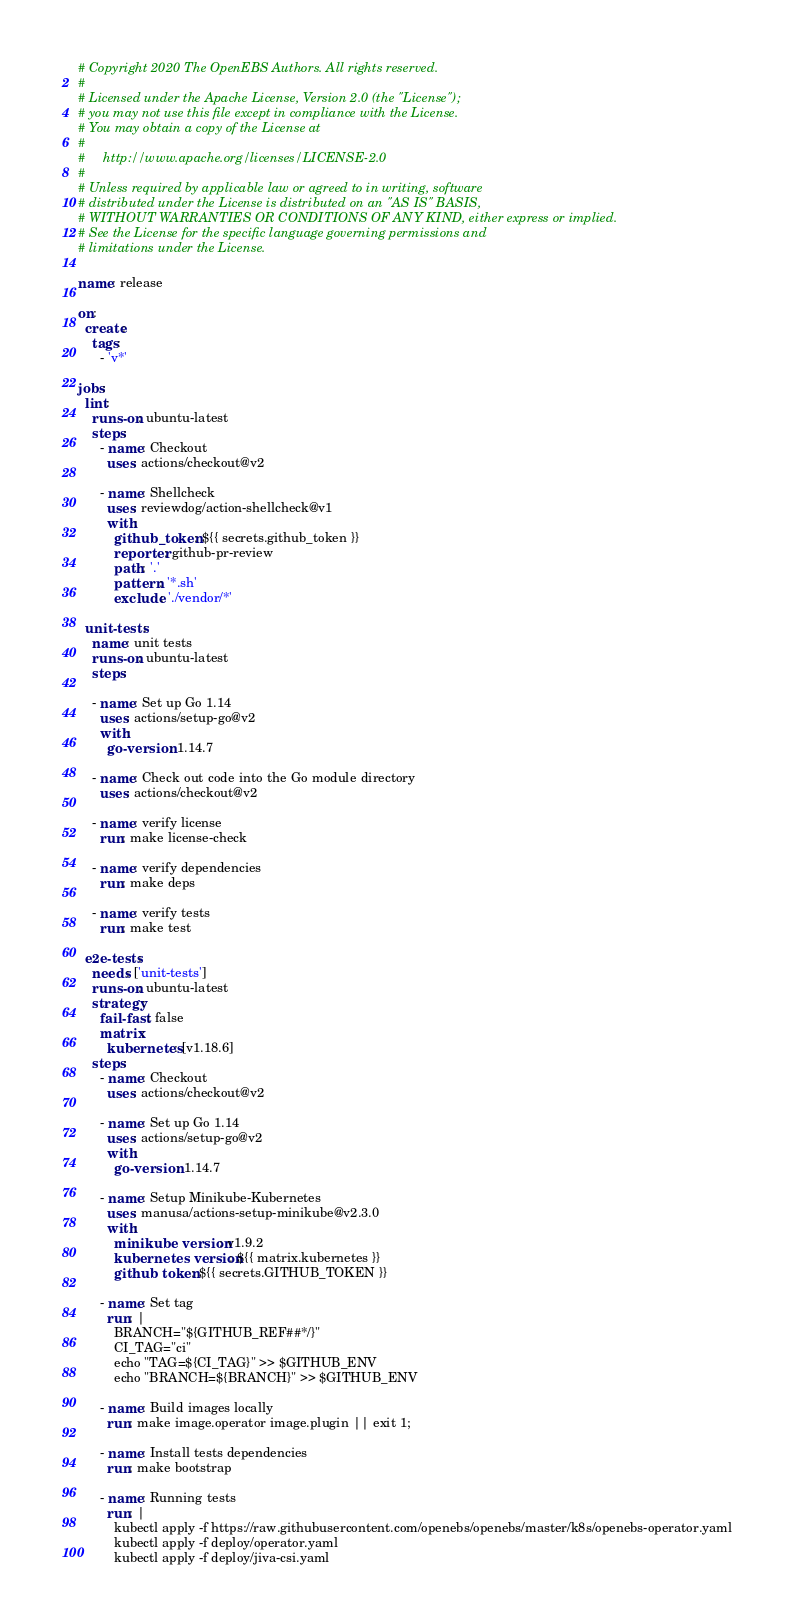Convert code to text. <code><loc_0><loc_0><loc_500><loc_500><_YAML_># Copyright 2020 The OpenEBS Authors. All rights reserved.
#
# Licensed under the Apache License, Version 2.0 (the "License");
# you may not use this file except in compliance with the License.
# You may obtain a copy of the License at
#
#     http://www.apache.org/licenses/LICENSE-2.0
#
# Unless required by applicable law or agreed to in writing, software
# distributed under the License is distributed on an "AS IS" BASIS,
# WITHOUT WARRANTIES OR CONDITIONS OF ANY KIND, either express or implied.
# See the License for the specific language governing permissions and
# limitations under the License.

name: release

on:
  create:
    tags:
      - 'v*'

jobs:
  lint:
    runs-on: ubuntu-latest
    steps:
      - name: Checkout
        uses: actions/checkout@v2

      - name: Shellcheck
        uses: reviewdog/action-shellcheck@v1
        with:
          github_token: ${{ secrets.github_token }}
          reporter: github-pr-review
          path: '.'
          pattern: '*.sh'
          exclude: './vendor/*'

  unit-tests:
    name: unit tests 
    runs-on: ubuntu-latest
    steps:

    - name: Set up Go 1.14
      uses: actions/setup-go@v2
      with:
        go-version: 1.14.7

    - name: Check out code into the Go module directory
      uses: actions/checkout@v2

    - name: verify license
      run: make license-check

    - name: verify dependencies
      run: make deps

    - name: verify tests
      run: make test

  e2e-tests:
    needs: ['unit-tests']
    runs-on: ubuntu-latest
    strategy:
      fail-fast: false
      matrix:
        kubernetes: [v1.18.6]
    steps:
      - name: Checkout
        uses: actions/checkout@v2

      - name: Set up Go 1.14
        uses: actions/setup-go@v2
        with:
          go-version: 1.14.7

      - name: Setup Minikube-Kubernetes
        uses: manusa/actions-setup-minikube@v2.3.0
        with:
          minikube version: v1.9.2
          kubernetes version: ${{ matrix.kubernetes }}
          github token: ${{ secrets.GITHUB_TOKEN }}

      - name: Set tag
        run: |
          BRANCH="${GITHUB_REF##*/}"
          CI_TAG="ci"
          echo "TAG=${CI_TAG}" >> $GITHUB_ENV
          echo "BRANCH=${BRANCH}" >> $GITHUB_ENV

      - name: Build images locally
        run: make image.operator image.plugin || exit 1;

      - name: Install tests dependencies
        run: make bootstrap

      - name: Running tests
        run: |
          kubectl apply -f https://raw.githubusercontent.com/openebs/openebs/master/k8s/openebs-operator.yaml
          kubectl apply -f deploy/operator.yaml
          kubectl apply -f deploy/jiva-csi.yaml</code> 